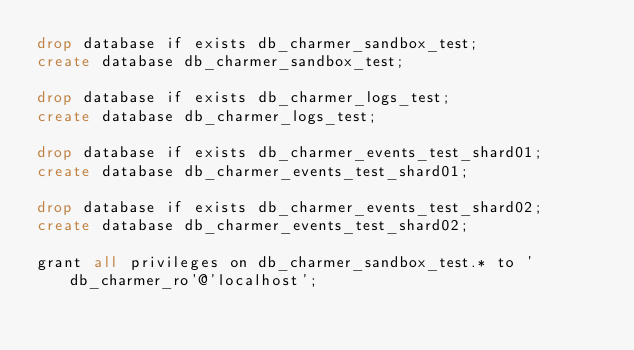Convert code to text. <code><loc_0><loc_0><loc_500><loc_500><_SQL_>drop database if exists db_charmer_sandbox_test;
create database db_charmer_sandbox_test;

drop database if exists db_charmer_logs_test;
create database db_charmer_logs_test;

drop database if exists db_charmer_events_test_shard01;
create database db_charmer_events_test_shard01;

drop database if exists db_charmer_events_test_shard02;
create database db_charmer_events_test_shard02;

grant all privileges on db_charmer_sandbox_test.* to 'db_charmer_ro'@'localhost';
</code> 